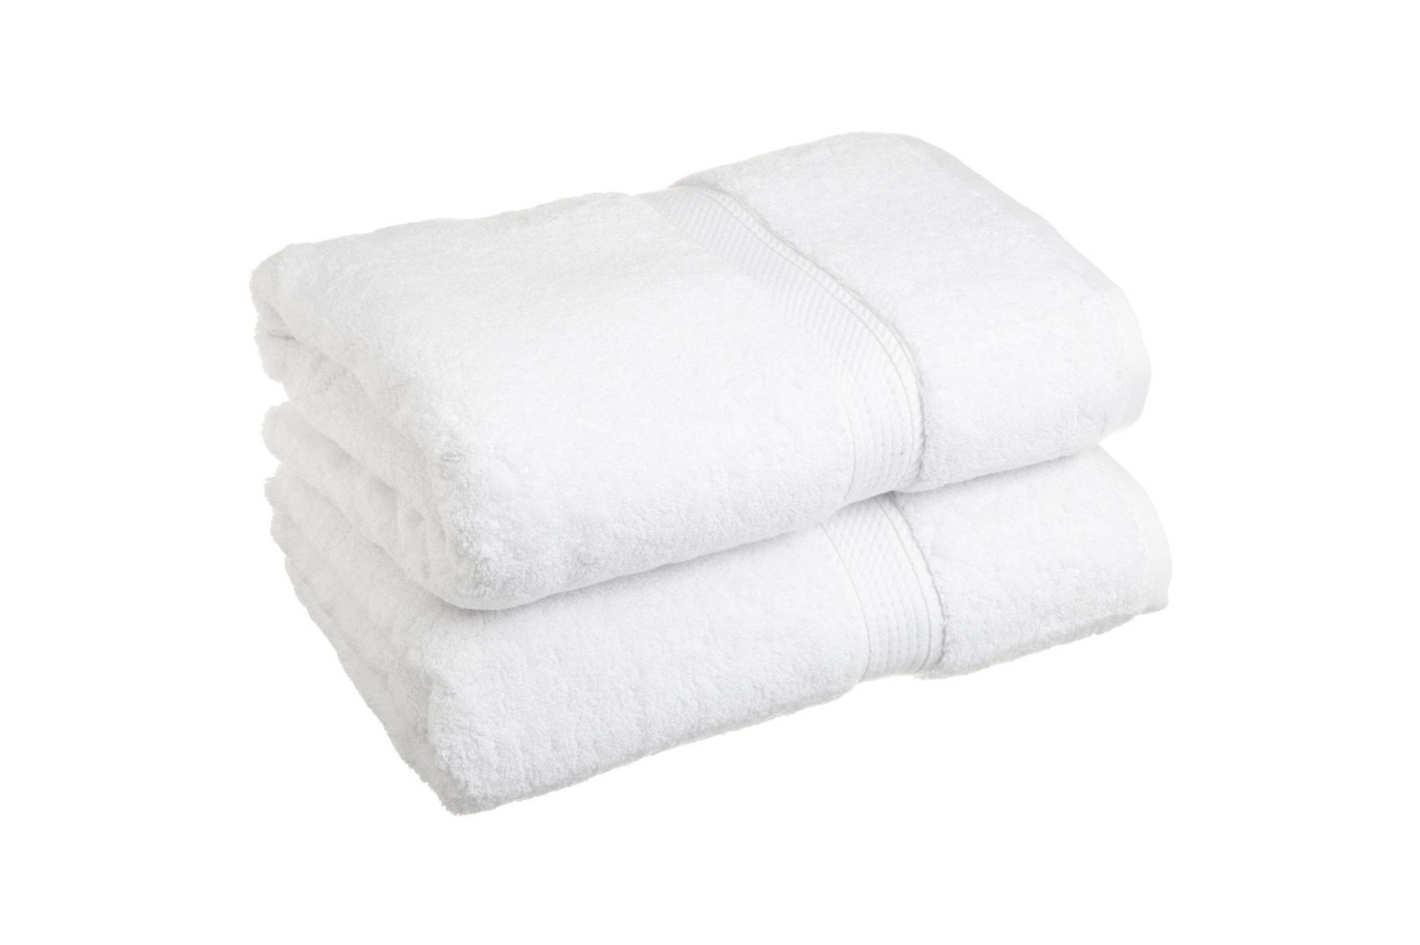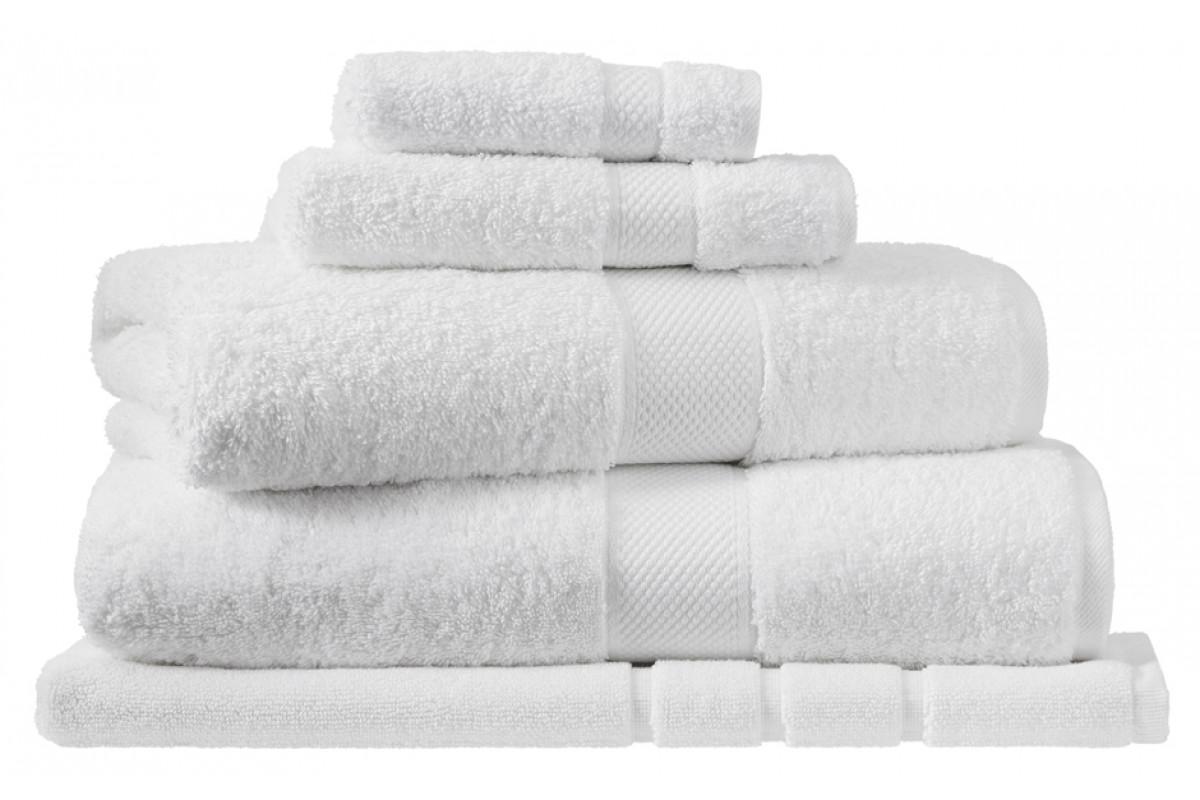The first image is the image on the left, the second image is the image on the right. Analyze the images presented: Is the assertion "There are exactly six folded items in the image on the right." valid? Answer yes or no. No. 